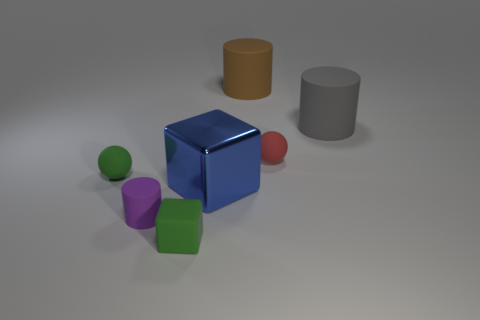Subtract all big gray cylinders. How many cylinders are left? 2 Add 1 big blue blocks. How many objects exist? 8 Subtract all brown cylinders. How many cylinders are left? 2 Subtract 2 balls. How many balls are left? 0 Subtract 0 brown spheres. How many objects are left? 7 Subtract all cylinders. How many objects are left? 4 Subtract all purple blocks. Subtract all red spheres. How many blocks are left? 2 Subtract all purple matte objects. Subtract all tiny green rubber objects. How many objects are left? 4 Add 2 large metallic objects. How many large metallic objects are left? 3 Add 7 tiny red rubber things. How many tiny red rubber things exist? 8 